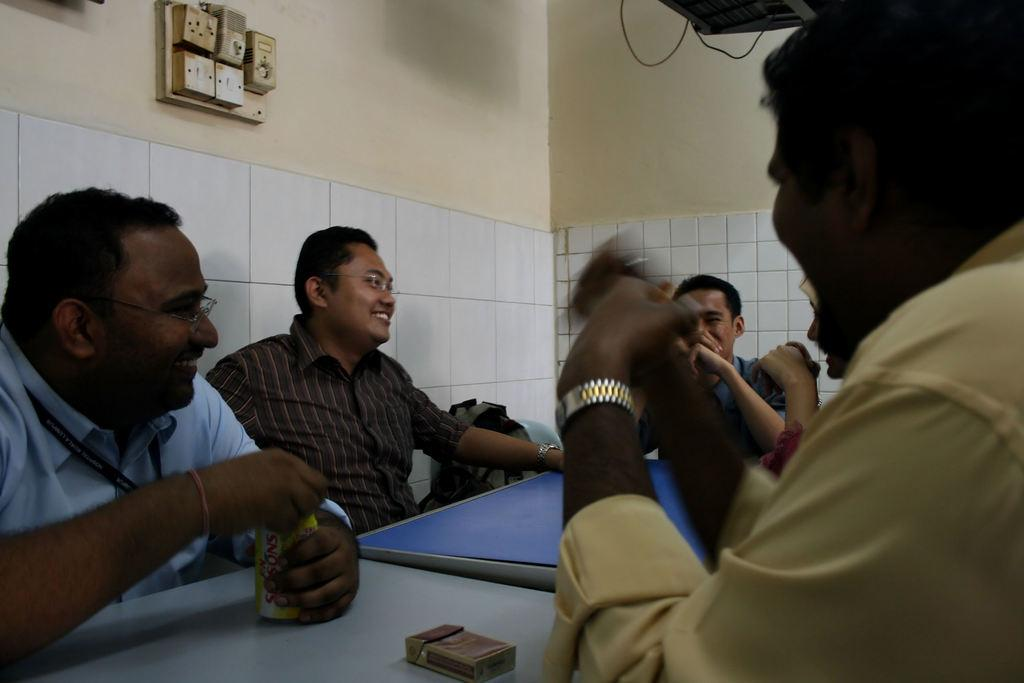What is happening in the image involving the group of people? The people in the image are seated and have smiles on their faces. What objects can be seen on the table in the image? There is a cigarette box and a can on the table in the image. What type of creature is flying over the group of people in the image? There are no creatures or planes visible in the image; it only features a group of seated people with smiles on their faces and a table with a cigarette box and a can. 